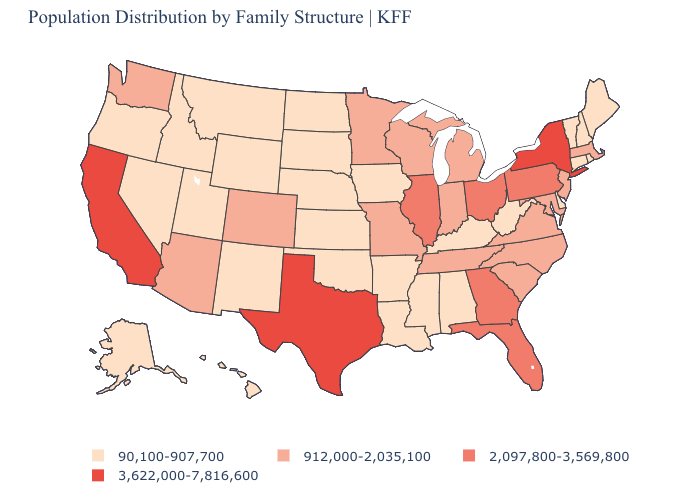Among the states that border Arkansas , which have the lowest value?
Concise answer only. Louisiana, Mississippi, Oklahoma. Name the states that have a value in the range 912,000-2,035,100?
Quick response, please. Arizona, Colorado, Indiana, Maryland, Massachusetts, Michigan, Minnesota, Missouri, New Jersey, North Carolina, South Carolina, Tennessee, Virginia, Washington, Wisconsin. What is the value of Florida?
Short answer required. 2,097,800-3,569,800. Does Iowa have the lowest value in the USA?
Keep it brief. Yes. How many symbols are there in the legend?
Write a very short answer. 4. Name the states that have a value in the range 912,000-2,035,100?
Answer briefly. Arizona, Colorado, Indiana, Maryland, Massachusetts, Michigan, Minnesota, Missouri, New Jersey, North Carolina, South Carolina, Tennessee, Virginia, Washington, Wisconsin. Does Oregon have the same value as Washington?
Concise answer only. No. What is the value of Nevada?
Keep it brief. 90,100-907,700. Name the states that have a value in the range 912,000-2,035,100?
Short answer required. Arizona, Colorado, Indiana, Maryland, Massachusetts, Michigan, Minnesota, Missouri, New Jersey, North Carolina, South Carolina, Tennessee, Virginia, Washington, Wisconsin. Does Tennessee have a lower value than Vermont?
Write a very short answer. No. Name the states that have a value in the range 90,100-907,700?
Keep it brief. Alabama, Alaska, Arkansas, Connecticut, Delaware, Hawaii, Idaho, Iowa, Kansas, Kentucky, Louisiana, Maine, Mississippi, Montana, Nebraska, Nevada, New Hampshire, New Mexico, North Dakota, Oklahoma, Oregon, Rhode Island, South Dakota, Utah, Vermont, West Virginia, Wyoming. Does Connecticut have the highest value in the Northeast?
Keep it brief. No. Does Alaska have the lowest value in the USA?
Be succinct. Yes. Does the map have missing data?
Answer briefly. No. 